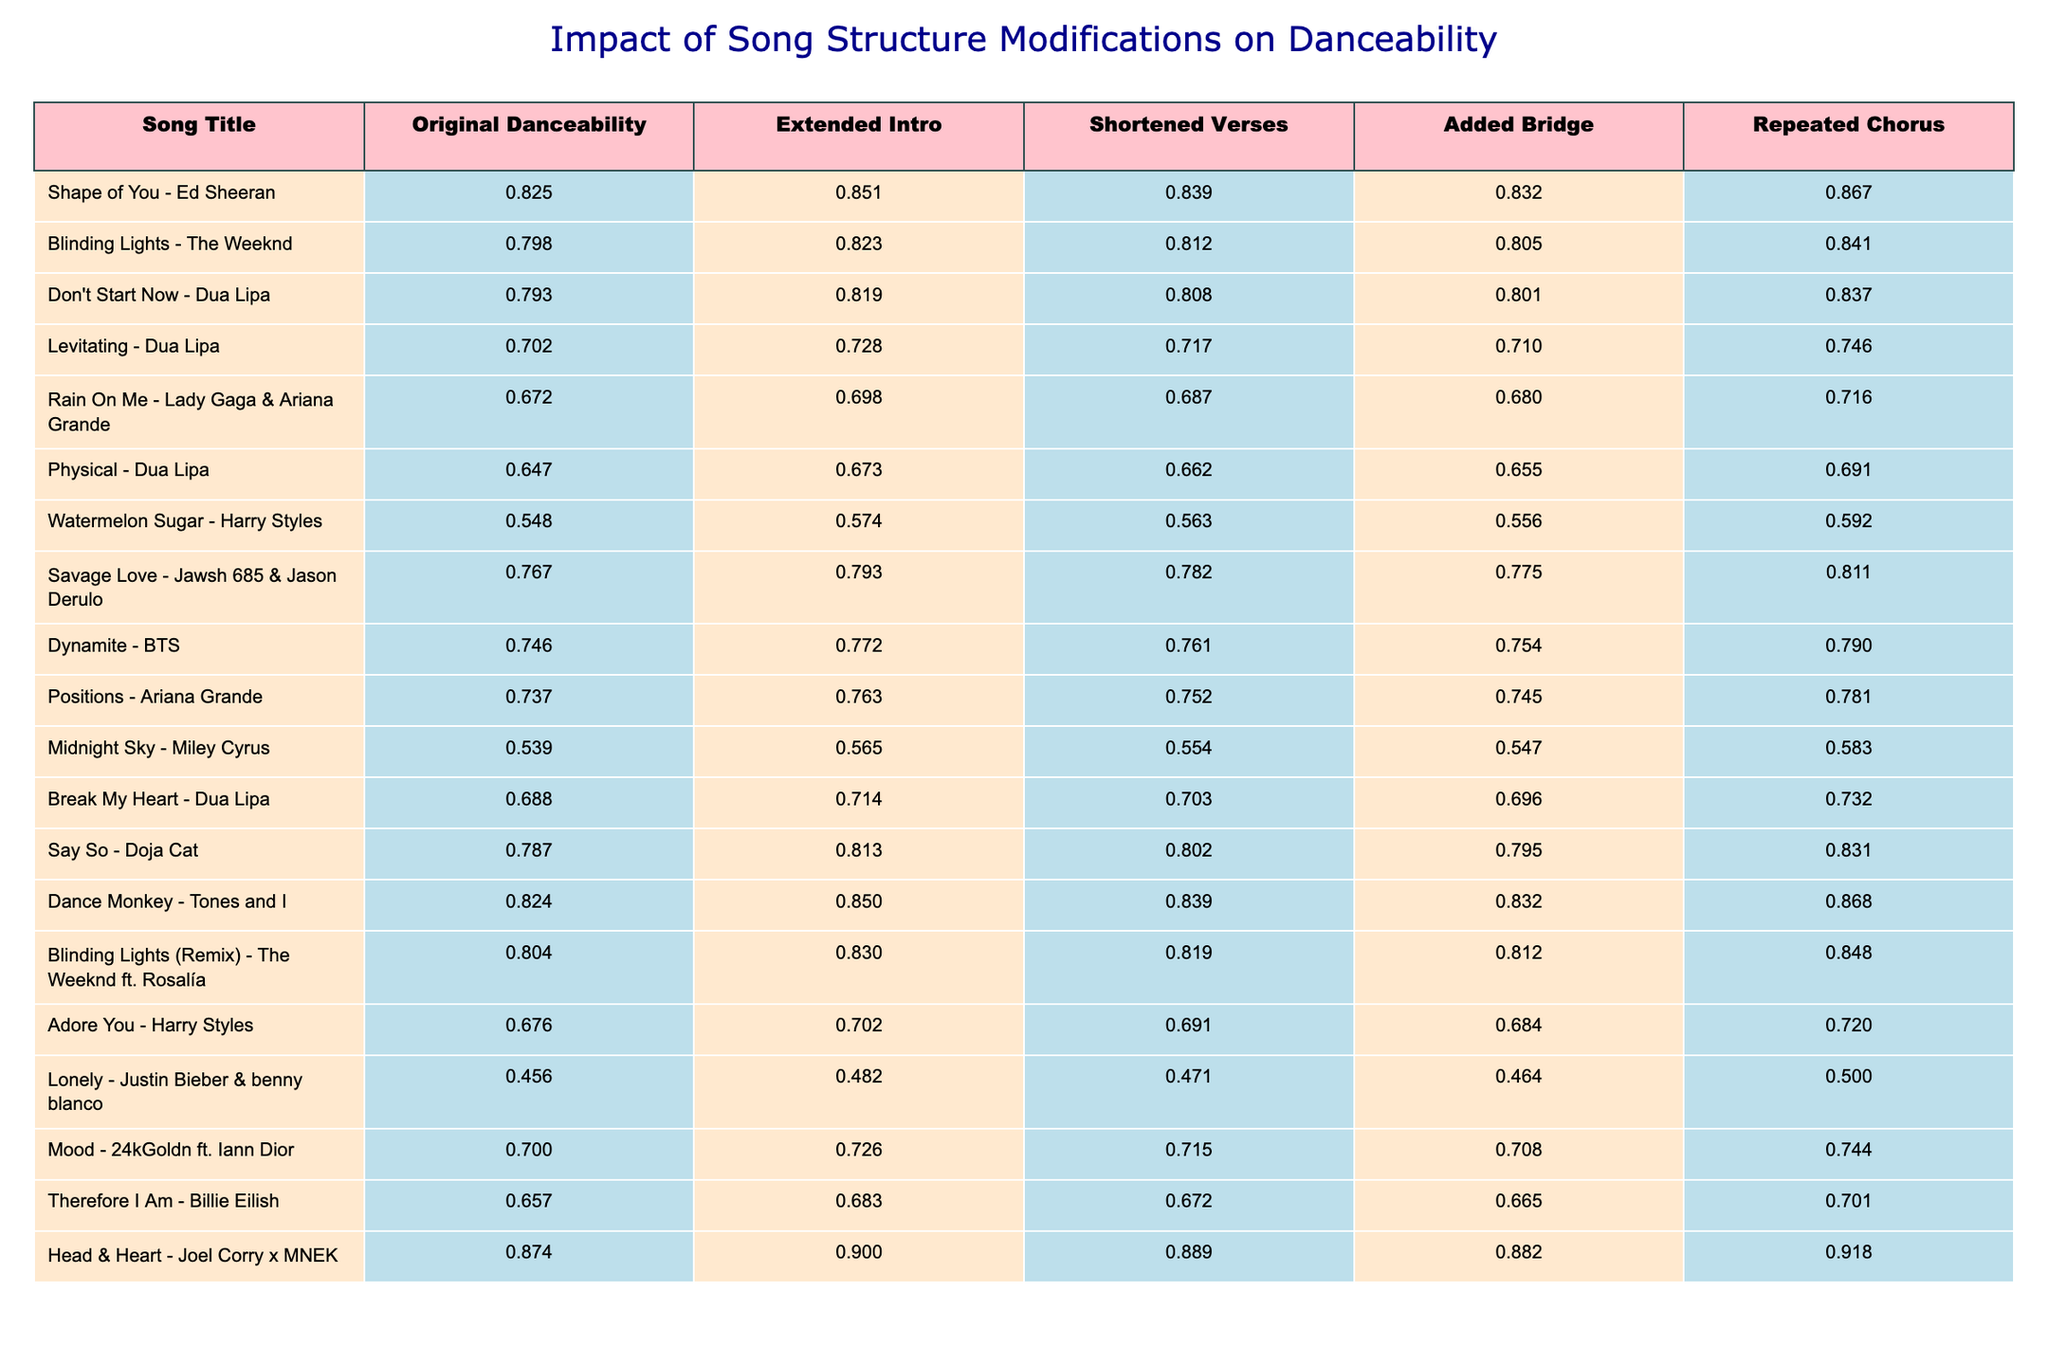What is the danceability rating of "Shape of You"? Referring to the table, the original danceability rating for "Shape of You" is listed as 0.825.
Answer: 0.825 Which song has the highest danceability rating in the original version? By examining the original danceability ratings in the table, "Head & Heart" has the highest rating at 0.874.
Answer: 0.874 What is the danceability rating of "Lonely" after the addition of a bridge? Looking at the table, the danceability rating for "Lonely" after the added bridge is 0.464.
Answer: 0.464 What modification seems to have the largest positive impact on the danceability of "Don't Start Now"? By comparing the danceability ratings, the repeated chorus for "Don't Start Now" increased the rating from 0.793 to 0.837, showing the largest positive change.
Answer: Repeated Chorus Calculate the average danceability rating of tracks after applying an extended intro. Summing the extended intro ratings: (0.851 + 0.823 + 0.819 + 0.728 + 0.698 + 0.673 + 0.574 + 0.793 + 0.772 + 0.763 + 0.565 + 0.714 + 0.813 + 0.850 + 0.830 + 0.702 + 0.726 + 0.683 + 0.900) gives 14.363 for 20 tracks. 14.363 / 20 = 0.718
Answer: 0.718 Is the shortened verses modification positively impacting the danceability for more songs than it negatively impacts? There are 8 songs where the danceability increased and 12 where it decreased when looking at the shortened verses modification, indicating more negative impacts.
Answer: No What is the difference in danceability ratings between "Blinding Lights" and "Dynamite"? The original danceability for "Blinding Lights" is 0.798 and for "Dynamite" it's 0.746. The difference is calculated as 0.798 - 0.746 = 0.052.
Answer: 0.052 Which song shows the biggest increase in danceability with a repeated chorus compared to its original rating? "Dance Monkey" shows an increase from 0.824 to 0.868, making it a difference of 0.044, which is the largest increase among the tracks in the table.
Answer: "Dance Monkey" How does the addition of an extended intro affect the danceability of "Levitating"? The original danceability of "Levitating" is 0.702, and with the extended intro, it improves to 0.728, showing a positive change.
Answer: Increased Which song has a consistent increase when applying all modifications? "Physical" maintains a consistent increase with each modification: from 0.647 to 0.673 to 0.662 to 0.655 to 0.691.
Answer: "Physical" 